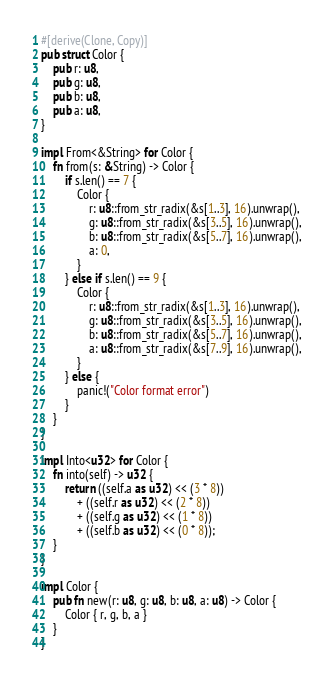Convert code to text. <code><loc_0><loc_0><loc_500><loc_500><_Rust_>#[derive(Clone, Copy)]
pub struct Color {
    pub r: u8,
    pub g: u8,
    pub b: u8,
    pub a: u8,
}

impl From<&String> for Color {
    fn from(s: &String) -> Color {
        if s.len() == 7 {
            Color {
                r: u8::from_str_radix(&s[1..3], 16).unwrap(),
                g: u8::from_str_radix(&s[3..5], 16).unwrap(),
                b: u8::from_str_radix(&s[5..7], 16).unwrap(),
                a: 0,
            }
        } else if s.len() == 9 {
            Color {
                r: u8::from_str_radix(&s[1..3], 16).unwrap(),
                g: u8::from_str_radix(&s[3..5], 16).unwrap(),
                b: u8::from_str_radix(&s[5..7], 16).unwrap(),
                a: u8::from_str_radix(&s[7..9], 16).unwrap(),
            }
        } else {
            panic!("Color format error")
        }
    }
}

impl Into<u32> for Color {
    fn into(self) -> u32 {
        return ((self.a as u32) << (3 * 8))
            + ((self.r as u32) << (2 * 8))
            + ((self.g as u32) << (1 * 8))
            + ((self.b as u32) << (0 * 8));
    }
}

impl Color {
    pub fn new(r: u8, g: u8, b: u8, a: u8) -> Color {
        Color { r, g, b, a }
    }
}
</code> 